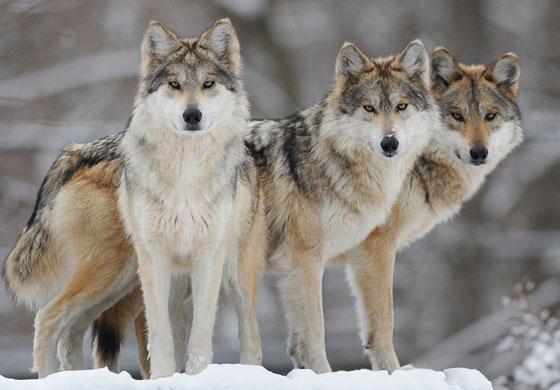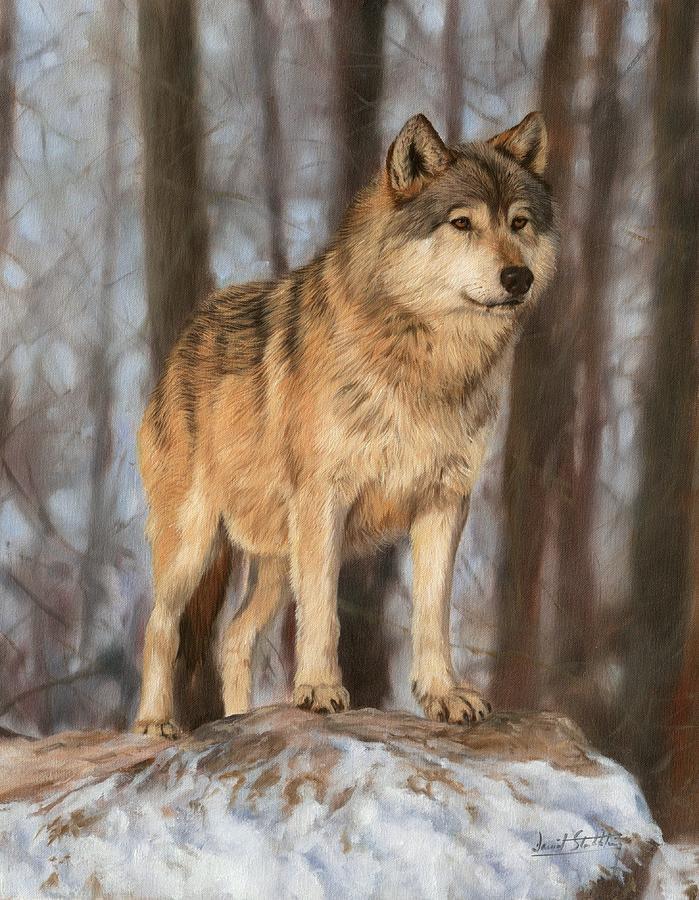The first image is the image on the left, the second image is the image on the right. Assess this claim about the two images: "The wolf in the right image is facing towards the right.". Correct or not? Answer yes or no. Yes. The first image is the image on the left, the second image is the image on the right. Given the left and right images, does the statement "One image includes at least three standing similar-looking wolves in a snowy scene." hold true? Answer yes or no. Yes. 